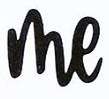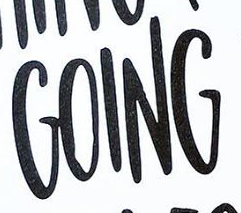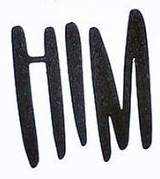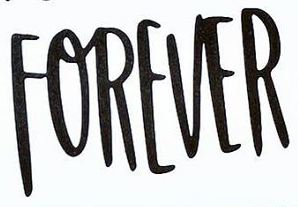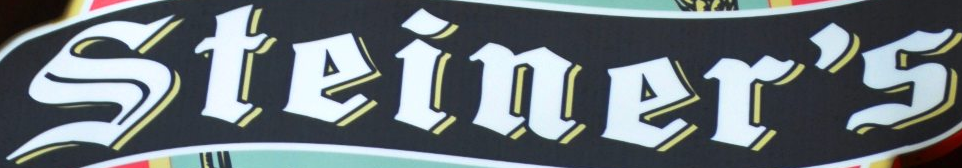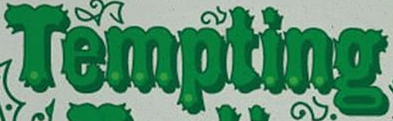Read the text from these images in sequence, separated by a semicolon. me; GOING; HIM; FOREVER; Steiner's; Tempting 